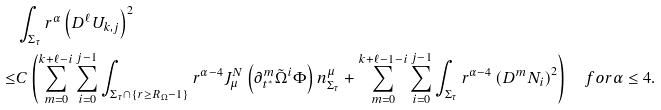<formula> <loc_0><loc_0><loc_500><loc_500>& \int _ { \Sigma _ { \tau } } r ^ { \alpha } \left ( D ^ { \ell } U _ { k , j } \right ) ^ { 2 } \\ \leq & C \left ( \sum _ { m = 0 } ^ { k + \ell - i } \sum _ { i = 0 } ^ { j - 1 } \int _ { \Sigma _ { \tau } \cap \{ r \geq R _ { \Omega } - 1 \} } r ^ { \alpha - 4 } J ^ { N } _ { \mu } \left ( \partial _ { t ^ { * } } ^ { m } \tilde { \Omega } ^ { i } \Phi \right ) n ^ { \mu } _ { \Sigma _ { \tau } } + \sum _ { m = 0 } ^ { k + \ell - 1 - i } \sum _ { i = 0 } ^ { j - 1 } \int _ { \Sigma _ { \tau } } r ^ { \alpha - 4 } \left ( D ^ { m } N _ { i } \right ) ^ { 2 } \right ) \quad f o r \alpha \leq 4 .</formula> 